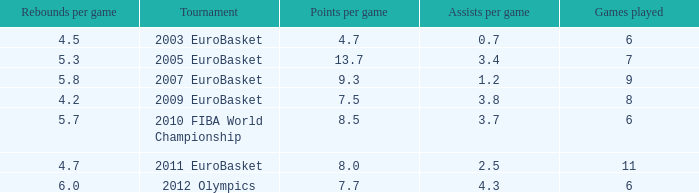How may assists per game have 7.7 points per game? 4.3. I'm looking to parse the entire table for insights. Could you assist me with that? {'header': ['Rebounds per game', 'Tournament', 'Points per game', 'Assists per game', 'Games played'], 'rows': [['4.5', '2003 EuroBasket', '4.7', '0.7', '6'], ['5.3', '2005 EuroBasket', '13.7', '3.4', '7'], ['5.8', '2007 EuroBasket', '9.3', '1.2', '9'], ['4.2', '2009 EuroBasket', '7.5', '3.8', '8'], ['5.7', '2010 FIBA World Championship', '8.5', '3.7', '6'], ['4.7', '2011 EuroBasket', '8.0', '2.5', '11'], ['6.0', '2012 Olympics', '7.7', '4.3', '6']]} 